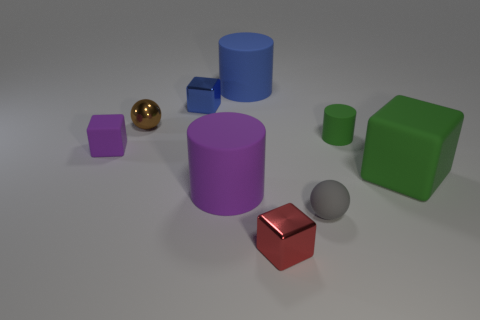Subtract all tiny cylinders. How many cylinders are left? 2 Subtract all green blocks. How many blocks are left? 3 Subtract all red cylinders. Subtract all blue cubes. How many cylinders are left? 3 Add 1 large green things. How many objects exist? 10 Subtract all blocks. How many objects are left? 5 Add 7 large blue cylinders. How many large blue cylinders are left? 8 Add 4 large brown rubber balls. How many large brown rubber balls exist? 4 Subtract 0 cyan balls. How many objects are left? 9 Subtract all purple objects. Subtract all small purple shiny blocks. How many objects are left? 7 